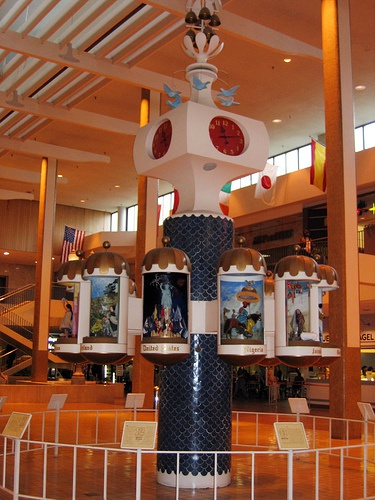Describe the objects in this image and their specific colors. I can see clock in gray, maroon, brown, and black tones, clock in gray, maroon, darkgray, and black tones, bird in gray and darkgray tones, bird in gray and maroon tones, and bird in gray and brown tones in this image. 